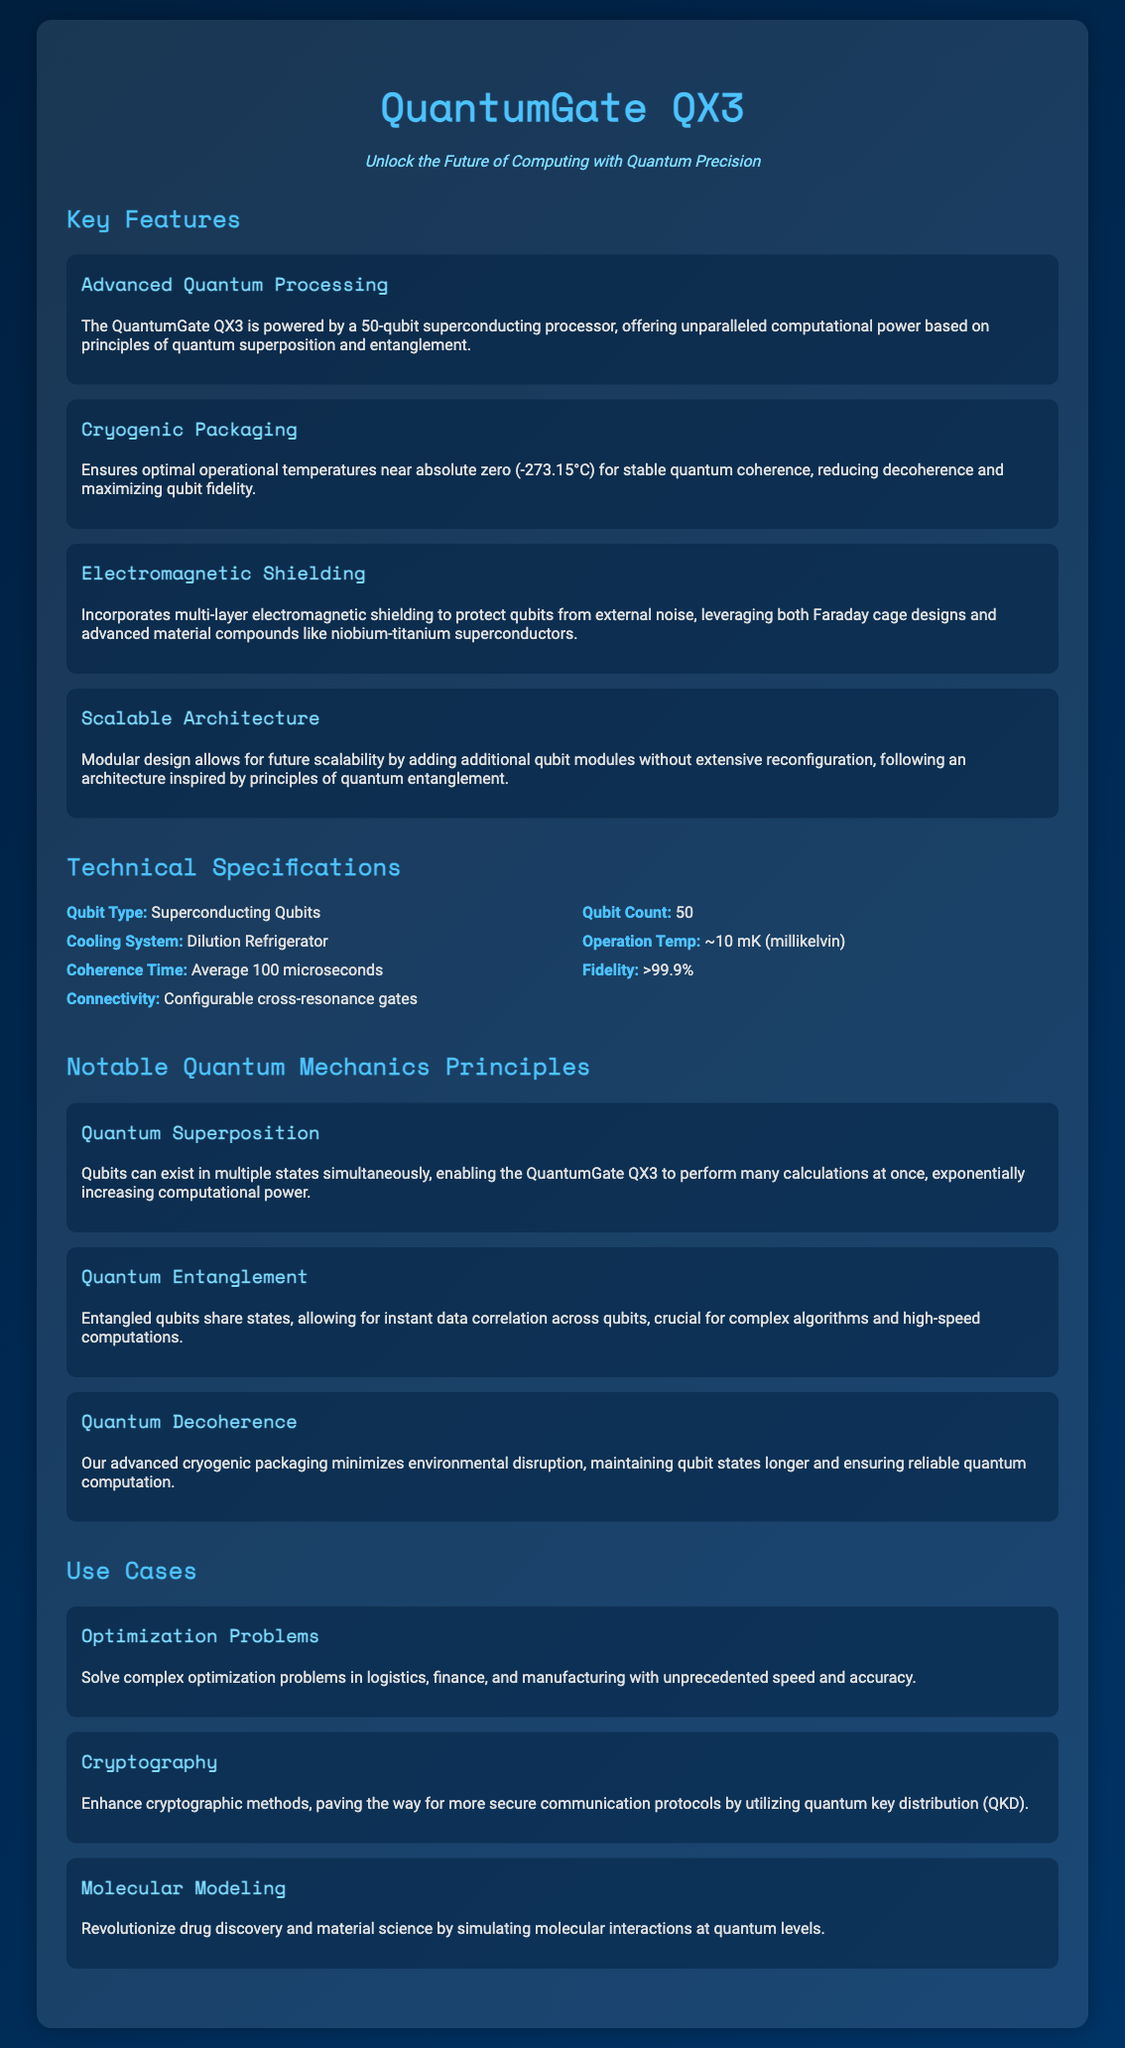What is the qubit count of the QuantumGate QX3? The qubit count is presented in the specifications section of the document, indicating it has 50 qubits.
Answer: 50 What type of cooling system does the QuantumGate QX3 use? The cooling system type is mentioned in the technical specifications, specifying it uses a Dilution Refrigerator.
Answer: Dilution Refrigerator What principle allows qubits to exist in multiple states simultaneously? The principle of Quantum Superposition is explained in the document, allowing qubits to exist in multiple states at once.
Answer: Quantum Superposition What is the average coherence time mentioned for the QuantumGate QX3? The average coherence time is listed in the technical specifications as 100 microseconds.
Answer: 100 microseconds Which feature protects qubits from external noise? The feature responsible for protecting qubits from noise is the Electromagnetic Shielding, described in the key features section.
Answer: Electromagnetic Shielding How does the QuantumGate QX3 enhance cryptographic methods? The document states it enhances cryptographic methods through quantum key distribution (QKD), specifically in the use cases section.
Answer: Quantum key distribution (QKD) What temperature does the QuantumGate QX3 operate near? The operational temperature for the device is specified as approximately 10 mK (millikelvin).
Answer: ~10 mK (millikelvin) What is one application of the QuantumGate QX3 in optimization problems? The document mentions solving complex optimization problems in logistics, finance, and manufacturing, highlighting its use case.
Answer: Logistics, finance, and manufacturing 